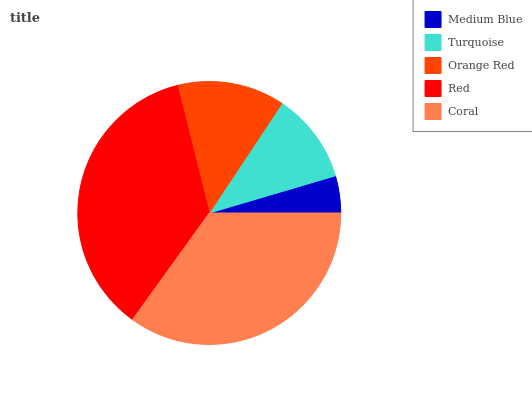Is Medium Blue the minimum?
Answer yes or no. Yes. Is Red the maximum?
Answer yes or no. Yes. Is Turquoise the minimum?
Answer yes or no. No. Is Turquoise the maximum?
Answer yes or no. No. Is Turquoise greater than Medium Blue?
Answer yes or no. Yes. Is Medium Blue less than Turquoise?
Answer yes or no. Yes. Is Medium Blue greater than Turquoise?
Answer yes or no. No. Is Turquoise less than Medium Blue?
Answer yes or no. No. Is Orange Red the high median?
Answer yes or no. Yes. Is Orange Red the low median?
Answer yes or no. Yes. Is Turquoise the high median?
Answer yes or no. No. Is Medium Blue the low median?
Answer yes or no. No. 